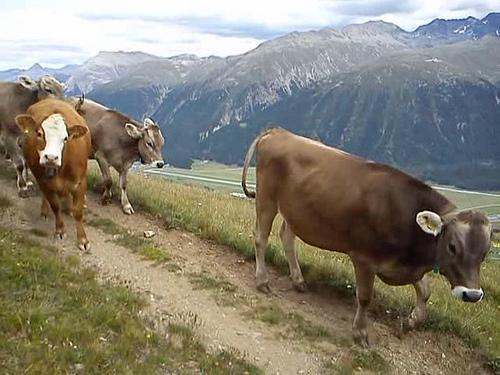Question: where is this scene?
Choices:
A. Picking blackberries in the thorny bushes.
B. Rescuing the kitten from the giant tree out back.
C. Going down a hillside on a dirt path.
D. The front of a house decorated beautiful for Christmas.
Answer with the letter. Answer: C Question: what is on the ground?
Choices:
A. Dirt.
B. Grass.
C. Rocks.
D. Flowers.
Answer with the letter. Answer: B Question: who is present?
Choices:
A. A man.
B. A woman.
C. A child.
D. No one.
Answer with the letter. Answer: D Question: how is the photo?
Choices:
A. Color.
B. Clear.
C. Black and white.
D. Lovely.
Answer with the letter. Answer: B Question: what are they doing?
Choices:
A. In motion.
B. Running.
C. Walking.
D. Talking.
Answer with the letter. Answer: A Question: what is this?
Choices:
A. Horse.
B. Sheep.
C. Goat.
D. Cow.
Answer with the letter. Answer: D 